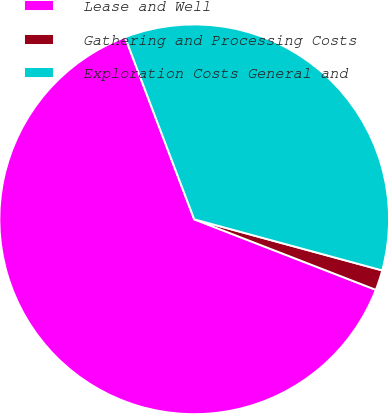Convert chart. <chart><loc_0><loc_0><loc_500><loc_500><pie_chart><fcel>Lease and Well<fcel>Gathering and Processing Costs<fcel>Exploration Costs General and<nl><fcel>63.33%<fcel>1.67%<fcel>35.0%<nl></chart> 